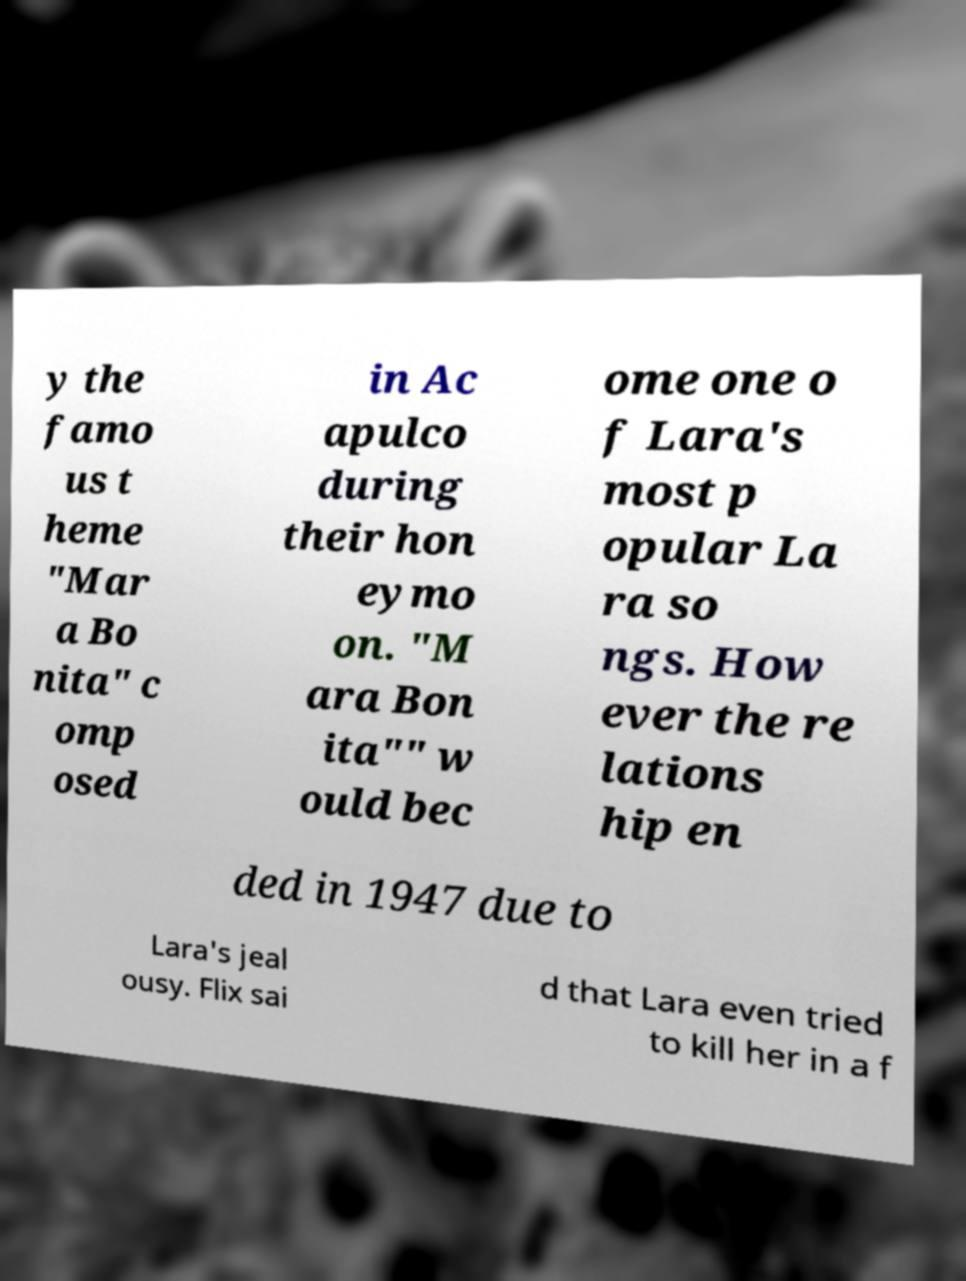Could you assist in decoding the text presented in this image and type it out clearly? y the famo us t heme "Mar a Bo nita" c omp osed in Ac apulco during their hon eymo on. "M ara Bon ita"" w ould bec ome one o f Lara's most p opular La ra so ngs. How ever the re lations hip en ded in 1947 due to Lara's jeal ousy. Flix sai d that Lara even tried to kill her in a f 